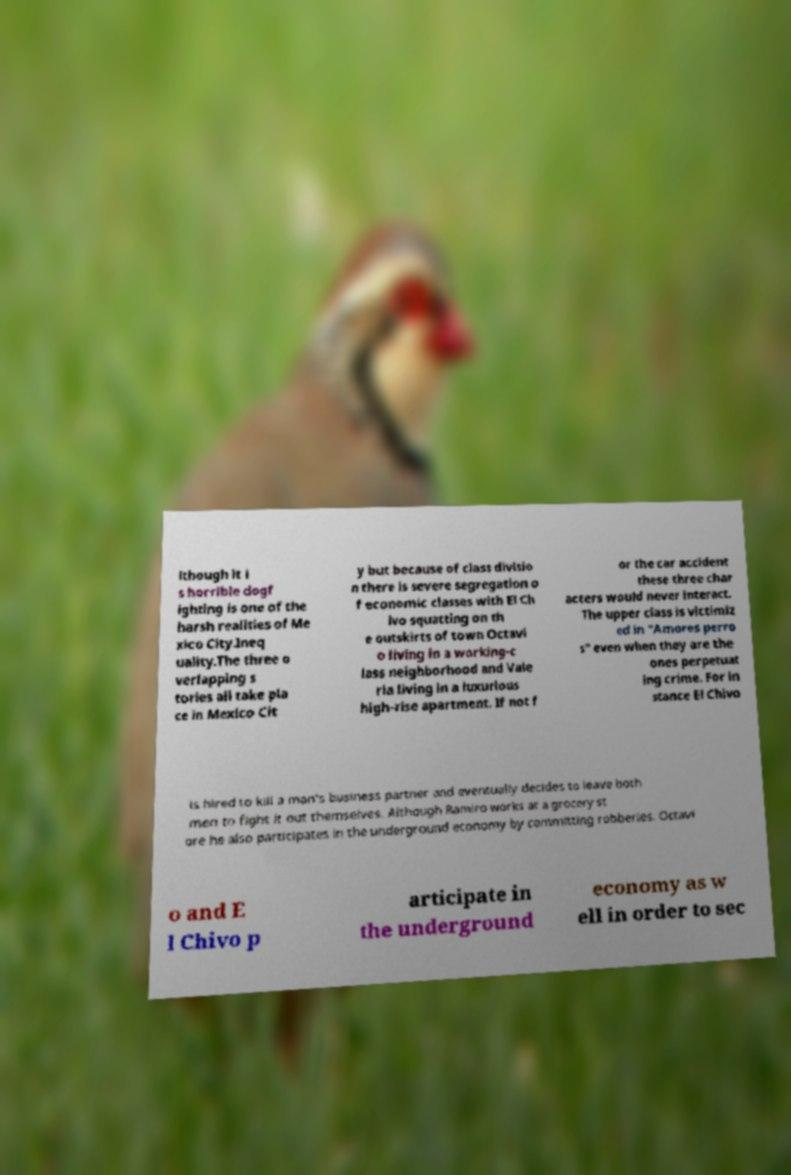Could you extract and type out the text from this image? lthough it i s horrible dogf ighting is one of the harsh realities of Me xico City.Ineq uality.The three o verlapping s tories all take pla ce in Mexico Cit y but because of class divisio n there is severe segregation o f economic classes with El Ch ivo squatting on th e outskirts of town Octavi o living in a working-c lass neighborhood and Vale ria living in a luxurious high-rise apartment. If not f or the car accident these three char acters would never interact. The upper class is victimiz ed in "Amores perro s" even when they are the ones perpetuat ing crime. For in stance El Chivo is hired to kill a man's business partner and eventually decides to leave both men to fight it out themselves. Although Ramiro works at a grocery st ore he also participates in the underground economy by committing robberies. Octavi o and E l Chivo p articipate in the underground economy as w ell in order to sec 